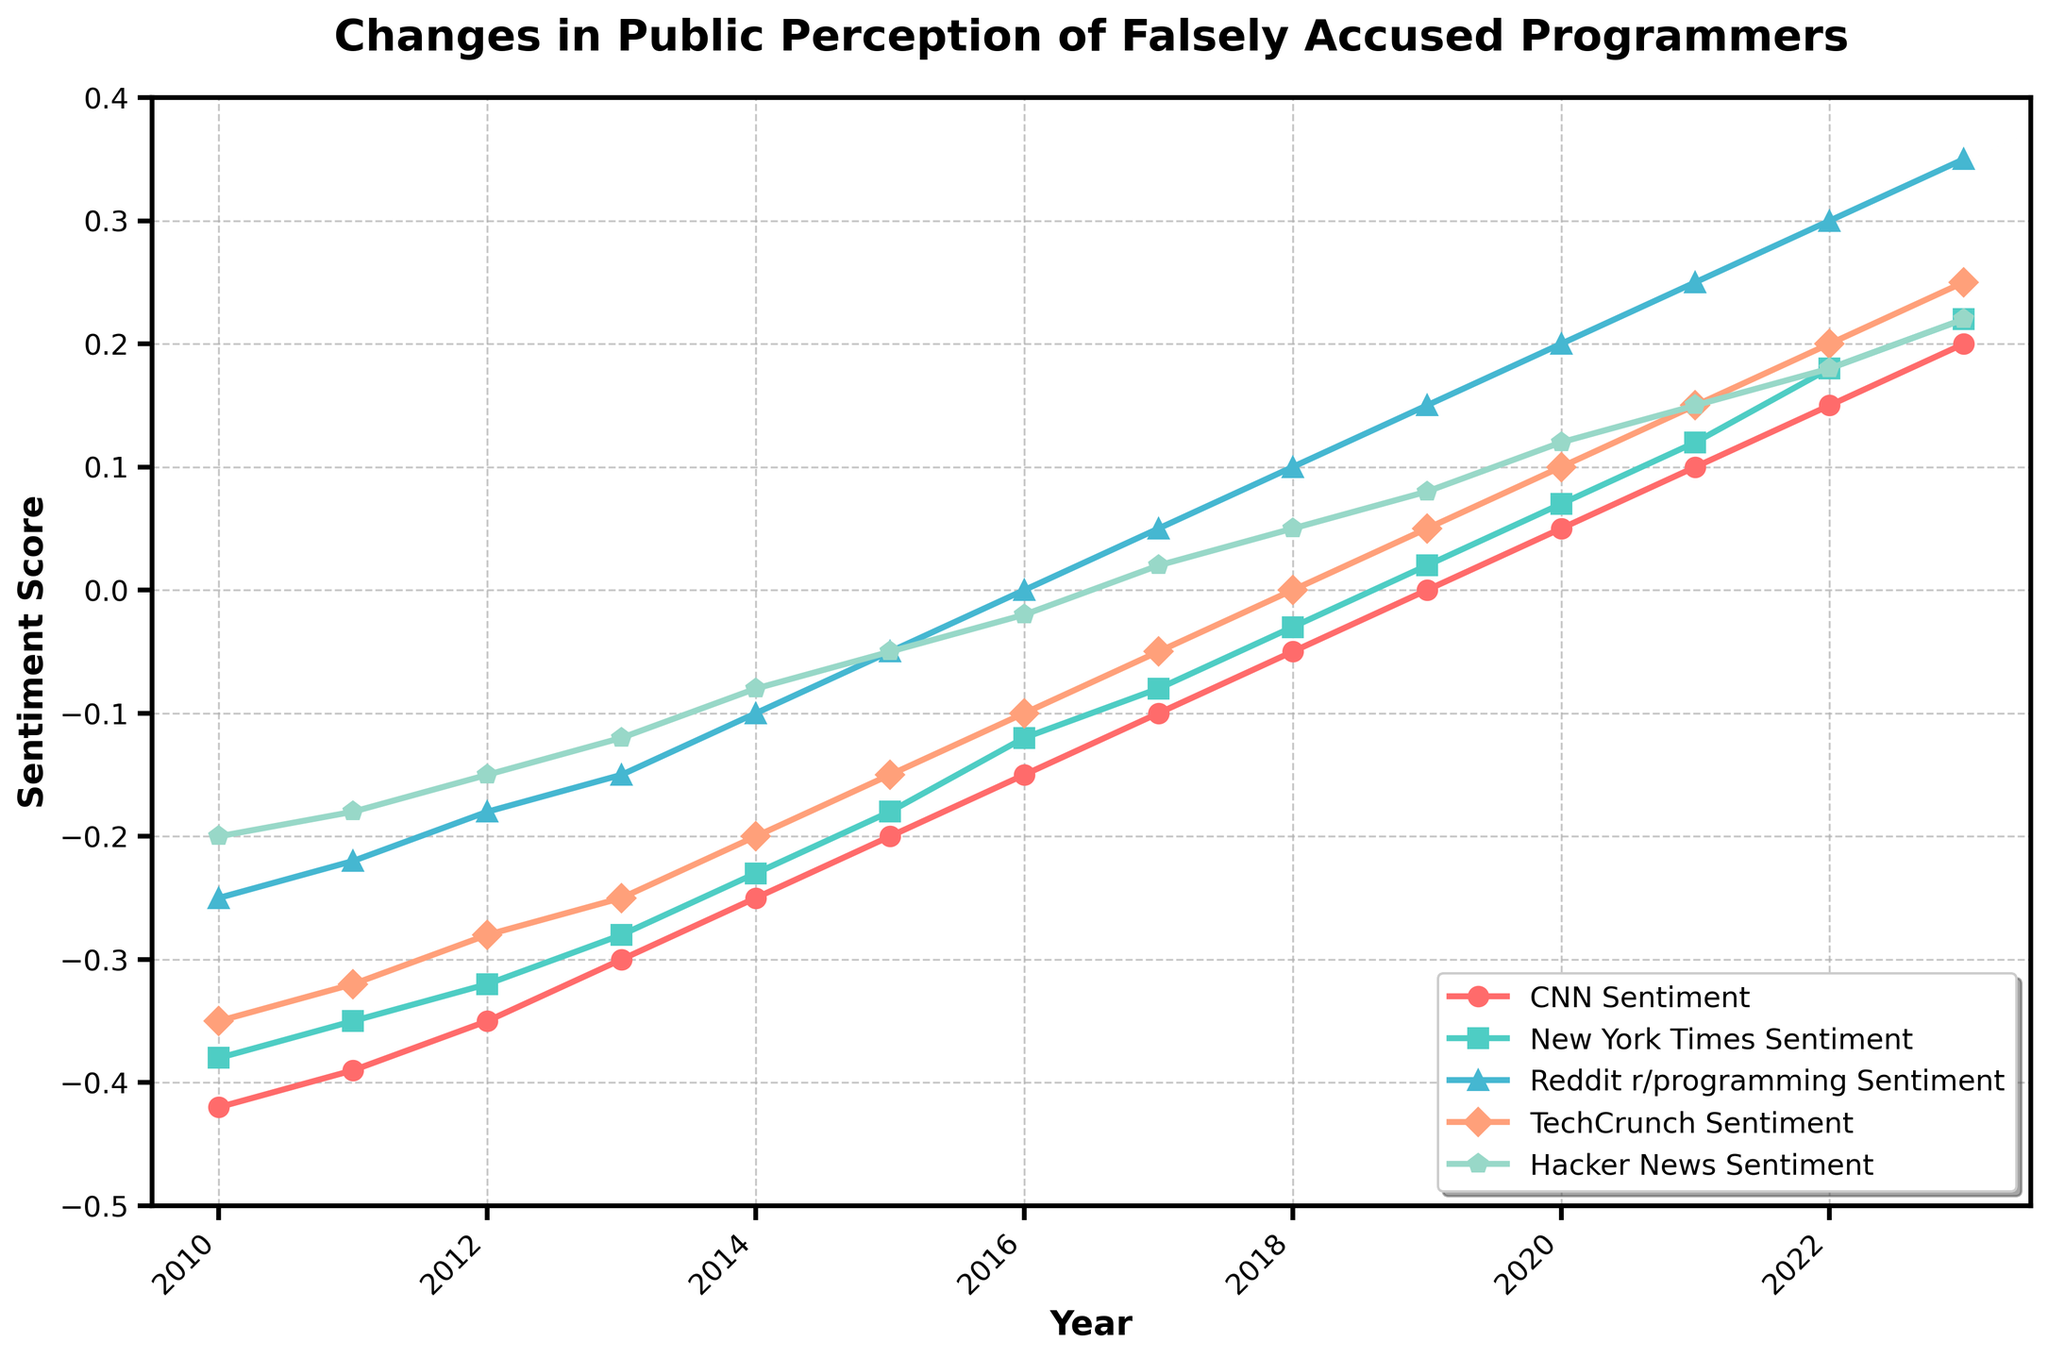How did CNN's sentiment change from 2010 to 2023? By looking at the plot, observe the sentiment score for CNN in 2010 and 2023. In 2010, it starts at -0.42 and in 2023, it reaches 0.20. Subtracting these values shows the change: 0.20 - (-0.42) = 0.62
Answer: 0.62 Which source had the most positive sentiment in 2023? By examining the sentiment scores in the plot for 2023, the highest sentiment score is 0.35 seen in Reddit r/programming. All other sources have lower values.
Answer: Reddit r/programming Between TechCrunch and Hacker News, which had a more significant positive change from 2010 to 2023? Looking at the sentiment scores for 2010 and 2023 for both sources: TechCrunch goes from -0.35 to 0.25 (change = 0.25 - (-0.35) = 0.60). Hacker News goes from -0.20 to 0.22 (change = 0.22 - (-0.20) = 0.42). Therefore, TechCrunch had the more significant positive change.
Answer: TechCrunch What is the average sentiment score of CNN over the 14-year period? Sum all yearly scores for CNN and divide by the number of years: (-0.42 + -0.39 + -0.35 + -0.30 + -0.25 + -0.20 + -0.15 + -0.10 + -0.05 + 0.00 + 0.05 + 0.10 + 0.15 + 0.20) / 14 = (-1.16) / 14 = -0.037
Answer: -0.037 Which year did the New York Times sentiment become positive? By inspecting the plot, find the year where the New York Times sentiment crossed from negative to positive. This happens in 2019 where the value is 0.02.
Answer: 2019 Compare the sentiment trend of Reddit r/programming and CNN; describe a key difference. Reddit r/programming starts with a slightly negative sentiment in 2010 and becomes increasingly positive, turning positive around 2016, and consistently rising thereafter. CNN also becomes more positive over time, but starts at a more negative value and rises more steadily. A key difference is the sharper increase and higher peak sentiment for Reddit r/programming in the later years.
Answer: Reddit r/programming has a sharper increase and higher peak sentiment in later years What was the sentiment score difference between TechCrunch and New York Times in 2018? Find the sentiment scores for TechCrunch and New York Times in 2018. TechCrunch is at 0.00 and New York Times is at -0.03. The difference is 0.00 - (-0.03) = 0.03.
Answer: 0.03 In which years did Hacker News sentiment score remain negative? Check the plot and identify years where Hacker News sentiment score is below 0. This occurs from 2010 to 2016 (inclusive).
Answer: 2010 to 2016 Calculate the total change for New York Times sentiment from 2010 to 2014. Sum the year-by-year changes from 2010 to 2014 for New York Times: -0.38 (2010), -0.35 (2011), -0.32 (2012), -0.28 (2013), -0.23 (2014). Change = -0.23 - (-0.38) = 0.15
Answer: 0.15 